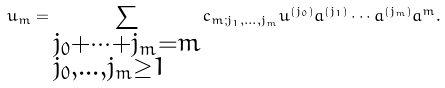<formula> <loc_0><loc_0><loc_500><loc_500>u _ { m } = \sum _ { \begin{subarray} { c } j _ { 0 } + \cdots + j _ { m } = m \\ j _ { 0 } , \dots , j _ { m } \geq 1 \end{subarray} } c _ { m ; j _ { 1 } , \dots , j _ { m } } u ^ { ( j _ { 0 } ) } a ^ { ( j _ { 1 } ) } \cdots a ^ { ( j _ { m } ) } a ^ { m } .</formula> 